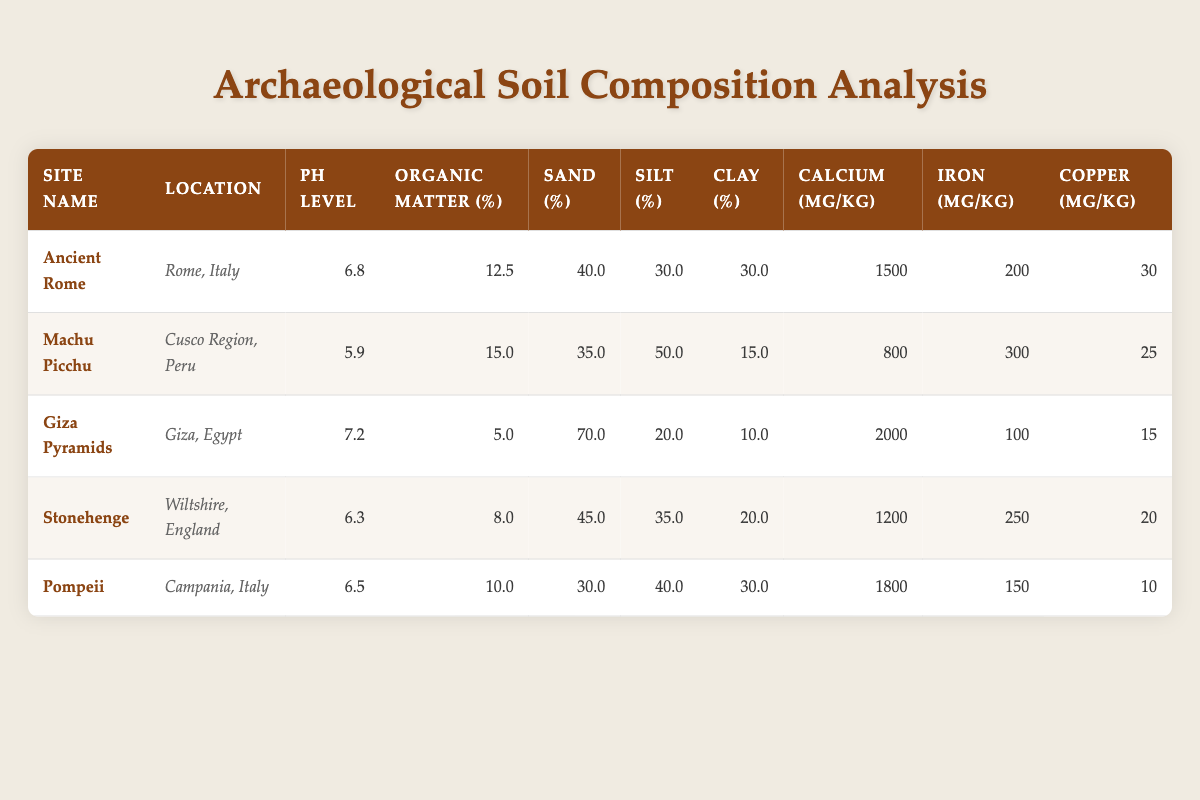What is the pH level of the Giza Pyramids? The pH level for the Giza Pyramids is listed directly in the table under the corresponding site. It states that the pH level is 7.2.
Answer: 7.2 Which site has the highest calcium content? To determine which site has the highest calcium content, we review the calcium content given in the table for all sites. The Giza Pyramids have 2000 mg/kg, which is higher than all the other sites listed.
Answer: Giza Pyramids What is the average organic matter percentage across all sites? First, we sum the organic matter percentages for each site: 12.5 + 15.0 + 5.0 + 8.0 + 10.0 = 50.5. There are 5 sites, so we divide 50.5 by 5 to find the average: 50.5 / 5 = 10.1.
Answer: 10.1 Is the iron content of Machu Picchu higher than that of Ancient Rome? The iron content for Machu Picchu is 300 mg/kg, while for Ancient Rome it is 200 mg/kg. Since 300 is greater than 200, the statement is true.
Answer: Yes Which site has the lowest clay percentage? We need to inspect the clay percentage for each site. The table shows that the Giza Pyramids have the lowest clay content at 10.0%, compared to other sites.
Answer: Giza Pyramids When comparing Stonehenge and Pompeii, which has a higher sand percentage? Stonehenge has a sand percentage of 45.0% and Pompeii has 30.0%. Since 45.0% is greater than 30.0%, Stonehenge has the higher sand percentage.
Answer: Stonehenge What is the total percentage of sand and silt for Ancient Rome? To find the total percentage, we add the sand percentage (40.0%) and the silt percentage (30.0%) for Ancient Rome: 40.0 + 30.0 = 70.0%.
Answer: 70.0% Is organic matter percentage greater than 15% at any site? Reviewing the organic matter percentages in the table, we find that Machu Picchu has 15.0% but not more than that. All other sites feature percentages below this value. Therefore, there is no site with an organic matter percentage greater than 15%.
Answer: No What is the difference in copper content between the site with the highest and the lowest copper levels? The site with the highest copper content is Ancient Rome with 30 mg/kg, and the site with the lowest is Pompeii with 10 mg/kg. The difference is calculated as 30 - 10 = 20 mg/kg.
Answer: 20 mg/kg 